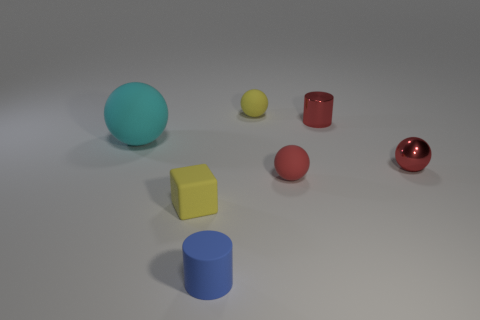Is there anything else that has the same size as the cyan rubber thing?
Your response must be concise. No. How many tiny red metal objects are behind the cyan rubber ball and on the right side of the metallic cylinder?
Offer a very short reply. 0. What number of other things are there of the same size as the cyan object?
Make the answer very short. 0. Is the number of small blue matte cylinders that are in front of the small rubber cylinder the same as the number of red rubber objects?
Ensure brevity in your answer.  No. Do the cylinder that is behind the metallic sphere and the tiny matte sphere that is in front of the cyan object have the same color?
Your answer should be very brief. Yes. What is the tiny object that is on the right side of the tiny red matte thing and behind the large matte sphere made of?
Ensure brevity in your answer.  Metal. The tiny rubber cylinder is what color?
Your answer should be very brief. Blue. How many other things are the same shape as the big cyan rubber object?
Provide a succinct answer. 3. Are there the same number of yellow cubes that are behind the shiny cylinder and tiny rubber balls that are in front of the blue object?
Offer a very short reply. Yes. What is the large cyan thing made of?
Keep it short and to the point. Rubber. 